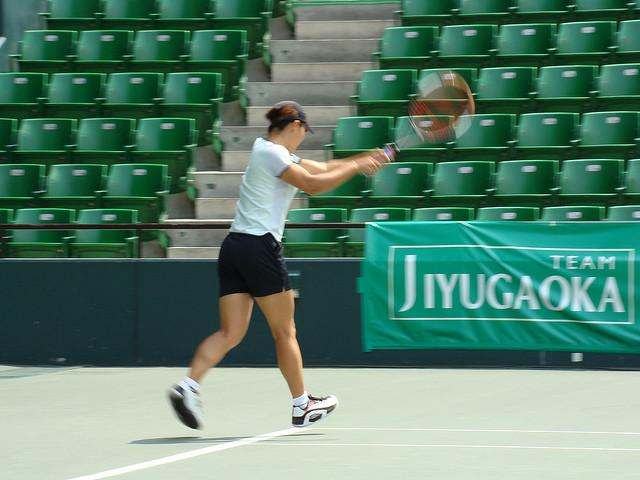What person played a similar sport to this person? Please explain your reasoning. martina navratilova. Martina is a famous tennis player, and the court and racquet used by this person suggests that they are playing tennis. 